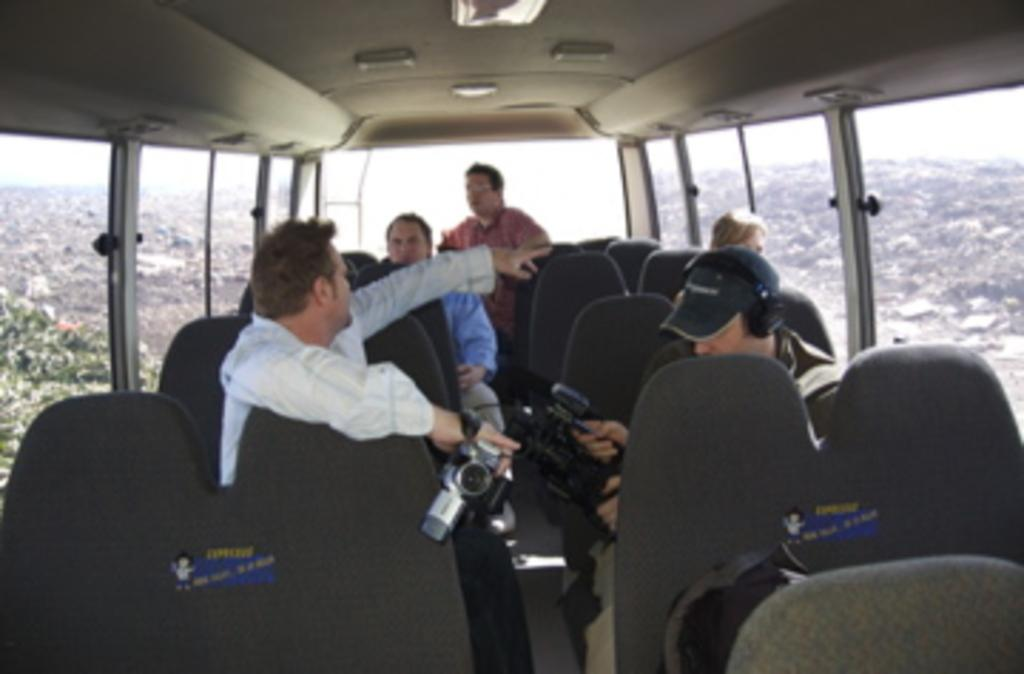How many people are in the vehicle in the image? There are five persons in the vehicle. What are two of the persons doing in the image? Two of the persons are holding cameras. Can you describe the background of the image? The background of the image is blurry. What type of bell can be heard ringing in the image? There is no bell present or audible in the image. How many circles are visible in the image? There are no circles visible in the image. 